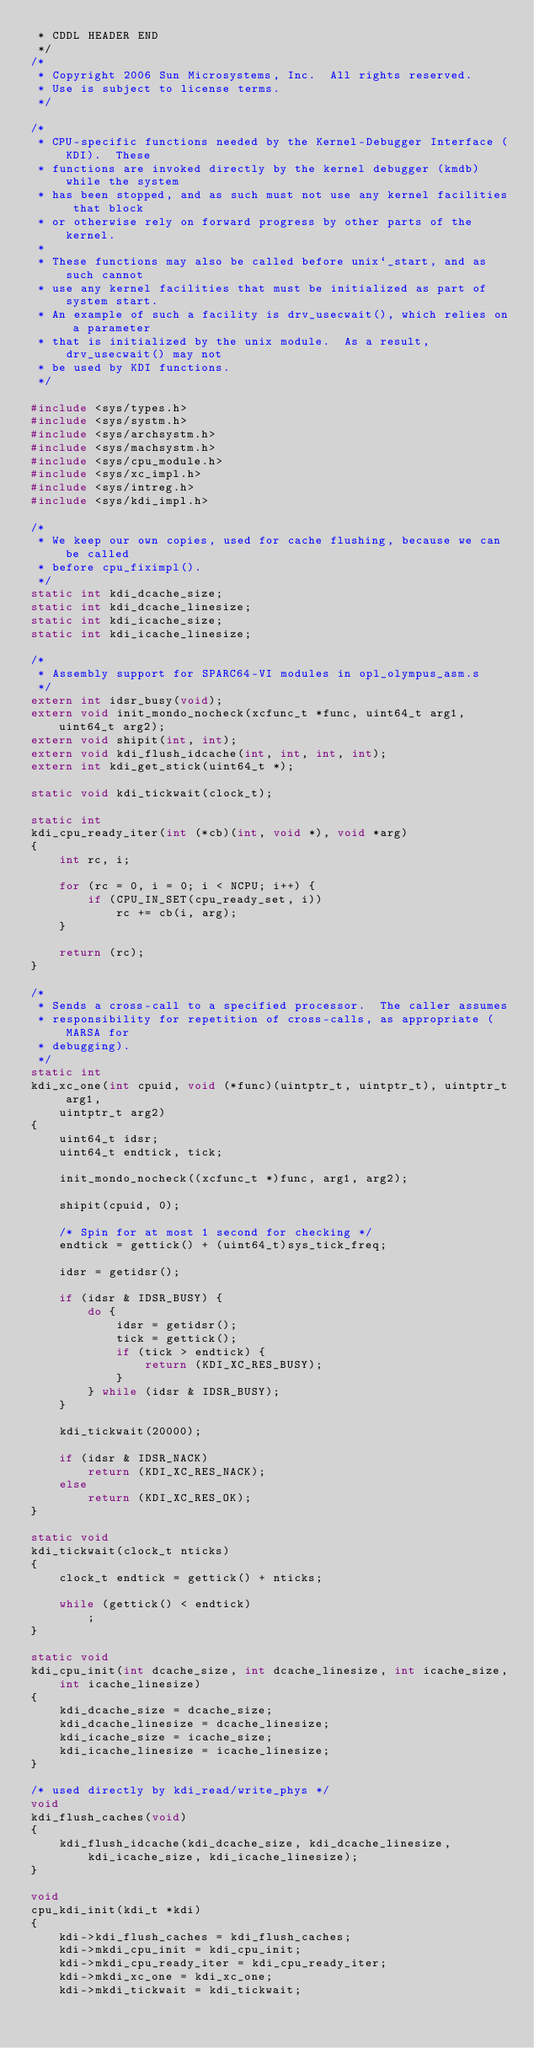Convert code to text. <code><loc_0><loc_0><loc_500><loc_500><_C_> * CDDL HEADER END
 */
/*
 * Copyright 2006 Sun Microsystems, Inc.  All rights reserved.
 * Use is subject to license terms.
 */

/*
 * CPU-specific functions needed by the Kernel-Debugger Interface (KDI).  These
 * functions are invoked directly by the kernel debugger (kmdb) while the system
 * has been stopped, and as such must not use any kernel facilities that block
 * or otherwise rely on forward progress by other parts of the kernel.
 *
 * These functions may also be called before unix`_start, and as such cannot
 * use any kernel facilities that must be initialized as part of system start.
 * An example of such a facility is drv_usecwait(), which relies on a parameter
 * that is initialized by the unix module.  As a result, drv_usecwait() may not
 * be used by KDI functions.
 */

#include <sys/types.h>
#include <sys/systm.h>
#include <sys/archsystm.h>
#include <sys/machsystm.h>
#include <sys/cpu_module.h>
#include <sys/xc_impl.h>
#include <sys/intreg.h>
#include <sys/kdi_impl.h>

/*
 * We keep our own copies, used for cache flushing, because we can be called
 * before cpu_fiximpl().
 */
static int kdi_dcache_size;
static int kdi_dcache_linesize;
static int kdi_icache_size;
static int kdi_icache_linesize;

/*
 * Assembly support for SPARC64-VI modules in opl_olympus_asm.s
 */
extern int idsr_busy(void);
extern void init_mondo_nocheck(xcfunc_t *func, uint64_t arg1, uint64_t arg2);
extern void shipit(int, int);
extern void kdi_flush_idcache(int, int, int, int);
extern int kdi_get_stick(uint64_t *);

static void kdi_tickwait(clock_t);

static int
kdi_cpu_ready_iter(int (*cb)(int, void *), void *arg)
{
	int rc, i;

	for (rc = 0, i = 0; i < NCPU; i++) {
		if (CPU_IN_SET(cpu_ready_set, i))
			rc += cb(i, arg);
	}

	return (rc);
}

/*
 * Sends a cross-call to a specified processor.  The caller assumes
 * responsibility for repetition of cross-calls, as appropriate (MARSA for
 * debugging).
 */
static int
kdi_xc_one(int cpuid, void (*func)(uintptr_t, uintptr_t), uintptr_t arg1,
    uintptr_t arg2)
{
	uint64_t idsr;
	uint64_t endtick, tick;

	init_mondo_nocheck((xcfunc_t *)func, arg1, arg2);

	shipit(cpuid, 0);

	/* Spin for at most 1 second for checking */
	endtick = gettick() + (uint64_t)sys_tick_freq;

	idsr = getidsr();

	if (idsr & IDSR_BUSY) {
		do {
			idsr = getidsr();
			tick = gettick();
			if (tick > endtick) {
				return (KDI_XC_RES_BUSY);
			}
		} while (idsr & IDSR_BUSY);
	}

	kdi_tickwait(20000);

	if (idsr & IDSR_NACK)
		return (KDI_XC_RES_NACK);
	else
		return (KDI_XC_RES_OK);
}

static void
kdi_tickwait(clock_t nticks)
{
	clock_t endtick = gettick() + nticks;

	while (gettick() < endtick)
		;
}

static void
kdi_cpu_init(int dcache_size, int dcache_linesize, int icache_size,
    int icache_linesize)
{
	kdi_dcache_size = dcache_size;
	kdi_dcache_linesize = dcache_linesize;
	kdi_icache_size = icache_size;
	kdi_icache_linesize = icache_linesize;
}

/* used directly by kdi_read/write_phys */
void
kdi_flush_caches(void)
{
	kdi_flush_idcache(kdi_dcache_size, kdi_dcache_linesize,
	    kdi_icache_size, kdi_icache_linesize);
}

void
cpu_kdi_init(kdi_t *kdi)
{
	kdi->kdi_flush_caches = kdi_flush_caches;
	kdi->mkdi_cpu_init = kdi_cpu_init;
	kdi->mkdi_cpu_ready_iter = kdi_cpu_ready_iter;
	kdi->mkdi_xc_one = kdi_xc_one;
	kdi->mkdi_tickwait = kdi_tickwait;</code> 